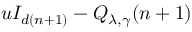Convert formula to latex. <formula><loc_0><loc_0><loc_500><loc_500>u I _ { d ( n + 1 ) } - Q _ { \lambda , \gamma } ( n + 1 )</formula> 